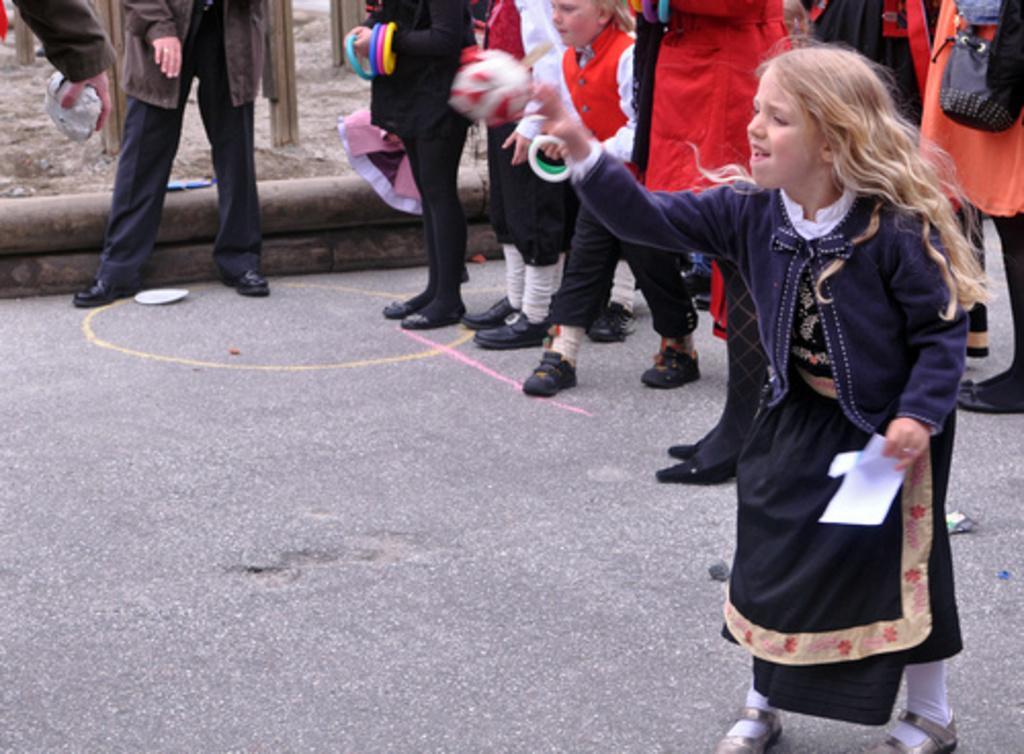Please provide a concise description of this image. In this picture we can see a group of people are standing, some of them are holding paper, objects in their hand. At the bottom of the image road is there. At the top of the image ground is there. 